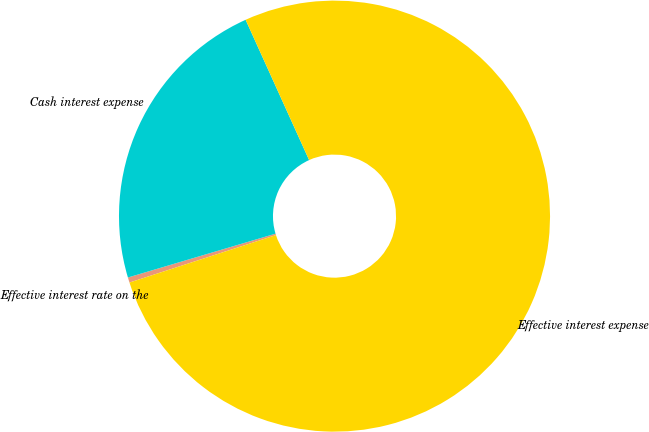<chart> <loc_0><loc_0><loc_500><loc_500><pie_chart><fcel>Effective interest rate on the<fcel>Cash interest expense<fcel>Effective interest expense<nl><fcel>0.39%<fcel>22.83%<fcel>76.78%<nl></chart> 